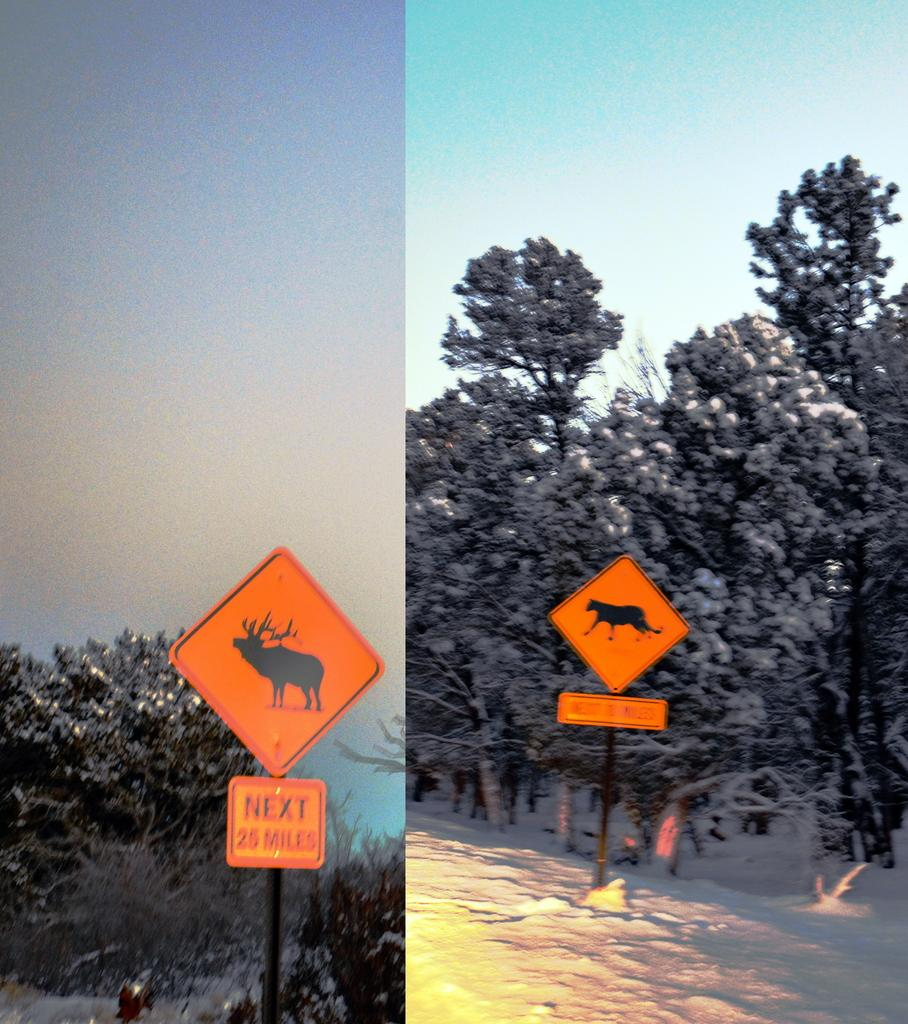What is the main subject of the image? The main subject of the image is a photo collage. What color are the sign boards in the image? The sign boards in the image are orange. What type of natural elements can be seen in the image? There are trees in the middle of the image. What is visible at the top of the image? The sky is visible at the top of the image. What type of drug is being sold on the orange sign boards in the image? There is no mention of drugs or any sign of drug sales in the image. The image only have no drugs in the image. The image only features a photo collage, orange sign boards, trees, and the sky. --- Facts: 1. There is a person sitting on a bench in the image. 2. The person is reading a book. 3. There is a tree behind the bench. 4. The sky is visible in the background. Absurd Topics: parrot, bicycle, ocean Conversation: What is the person in the image doing? The person in the image is reading a book. What is located behind the person? There is a tree behind the bench. What can be seen in the background of the image? The sky is visible in the background of the image. Reasoning: Let's think step by step in order to produce the conversation. We start by identifying the main subject of the image, which is the person sitting on a bench. Next, we describe the action of the person, which is reading a book. Then, we observe the elements in the background of the image, which includes a tree and the sky. Absurd Question/Answer: What type of parrot is sitting on the person's shoulder in the image? There is no parrot present in the image. 